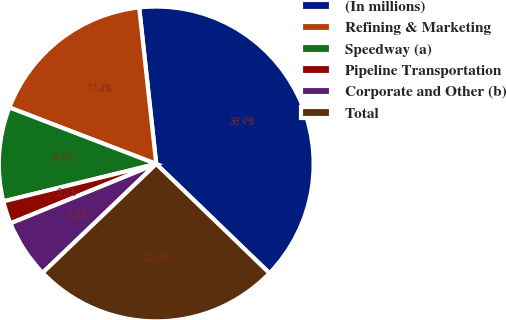<chart> <loc_0><loc_0><loc_500><loc_500><pie_chart><fcel>(In millions)<fcel>Refining & Marketing<fcel>Speedway (a)<fcel>Pipeline Transportation<fcel>Corporate and Other (b)<fcel>Total<nl><fcel>38.94%<fcel>17.43%<fcel>9.66%<fcel>2.34%<fcel>6.0%<fcel>25.62%<nl></chart> 